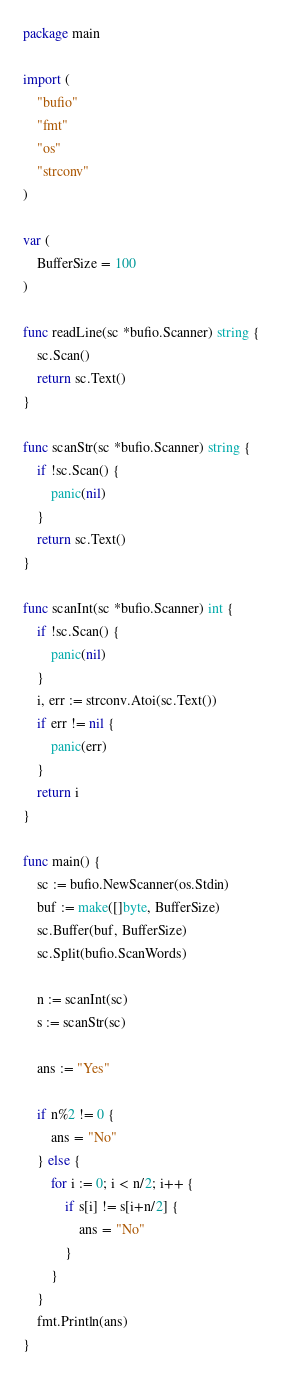Convert code to text. <code><loc_0><loc_0><loc_500><loc_500><_Go_>package main

import (
	"bufio"
	"fmt"
	"os"
	"strconv"
)

var (
	BufferSize = 100
)

func readLine(sc *bufio.Scanner) string {
	sc.Scan()
	return sc.Text()
}

func scanStr(sc *bufio.Scanner) string {
	if !sc.Scan() {
		panic(nil)
	}
	return sc.Text()
}

func scanInt(sc *bufio.Scanner) int {
	if !sc.Scan() {
		panic(nil)
	}
	i, err := strconv.Atoi(sc.Text())
	if err != nil {
		panic(err)
	}
	return i
}

func main() {
	sc := bufio.NewScanner(os.Stdin)
	buf := make([]byte, BufferSize)
	sc.Buffer(buf, BufferSize)
	sc.Split(bufio.ScanWords)

	n := scanInt(sc)
	s := scanStr(sc)

	ans := "Yes"

	if n%2 != 0 {
		ans = "No"
	} else {
		for i := 0; i < n/2; i++ {
			if s[i] != s[i+n/2] {
				ans = "No"
			}
		}
	}
	fmt.Println(ans)
}
</code> 